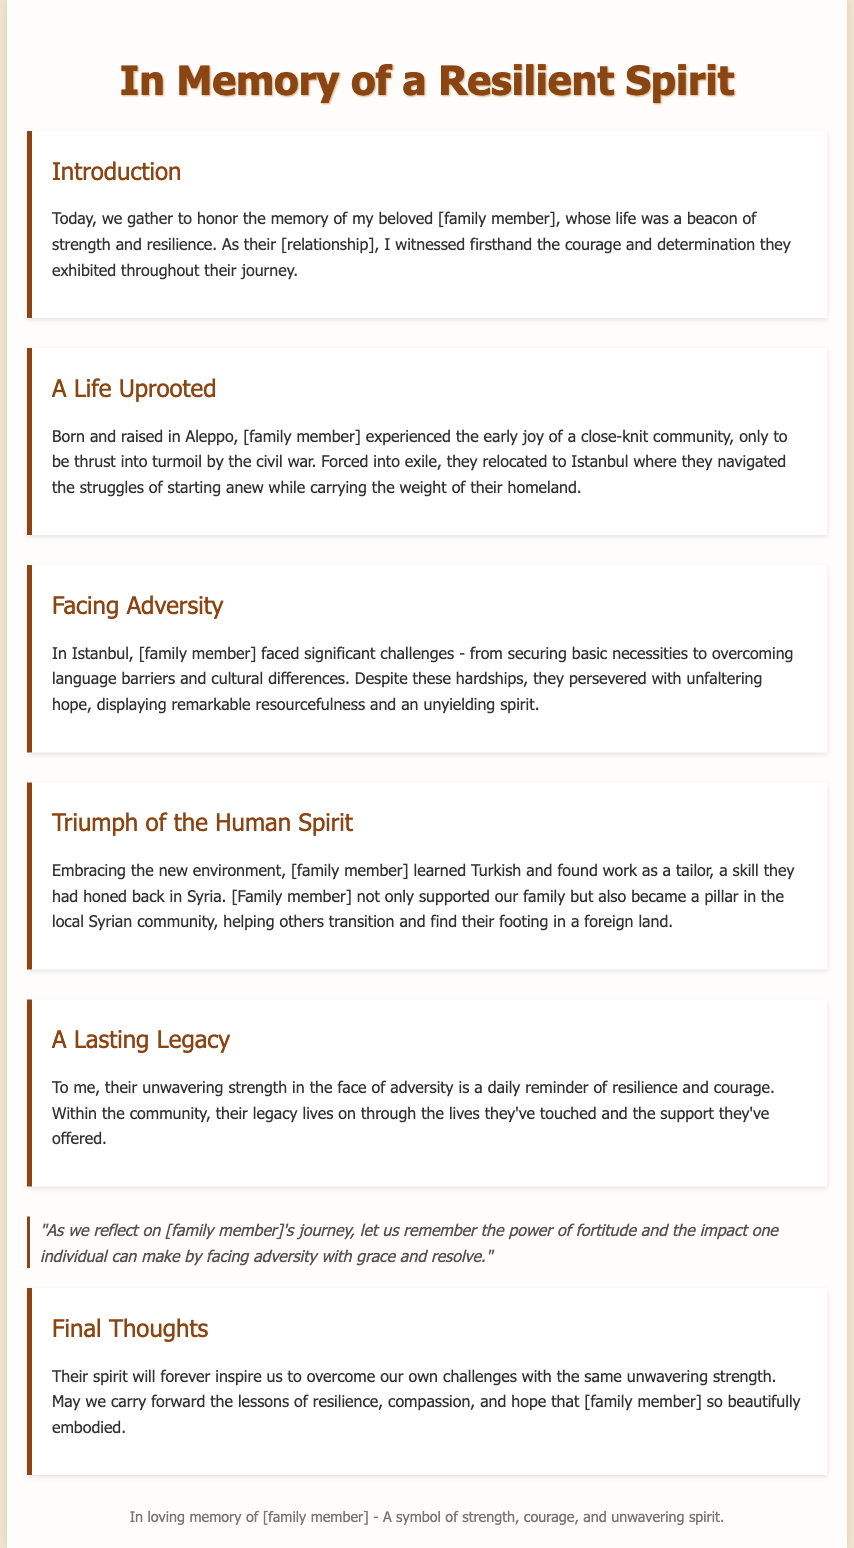what was the name of the city where the family member was born? The document states that the family member was born and raised in Aleppo.
Answer: Aleppo what challenges did the family member face in Istanbul? The document mentions significant challenges including securing basic necessities and overcoming language barriers.
Answer: Basic necessities and language barriers what skill did the family member utilize in their new job? The family member found work as a tailor and had honed this skill back in Syria.
Answer: Tailoring how did the family member contribute to the local community? The family member became a pillar in the local Syrian community by helping others transition.
Answer: Helping others transition what does the quote in the eulogy emphasize? The quote emphasizes the power of fortitude and the impact one individual can make when facing adversity.
Answer: Power of fortitude what is the relationship of the speaker to the family member? The document indicates that the speaker is the family member's [relationship], which is not specifically provided but implies a close connection.
Answer: [Relationship] how is the family member's legacy described? The family member's legacy is described as living on through the lives they've touched and the support they've offered.
Answer: Lives touched and support offered what is the main theme of the final thoughts section? The final thoughts express a desire to carry forward the lessons of resilience, compassion, and hope that the family member embodied.
Answer: Resilience, compassion, and hope 